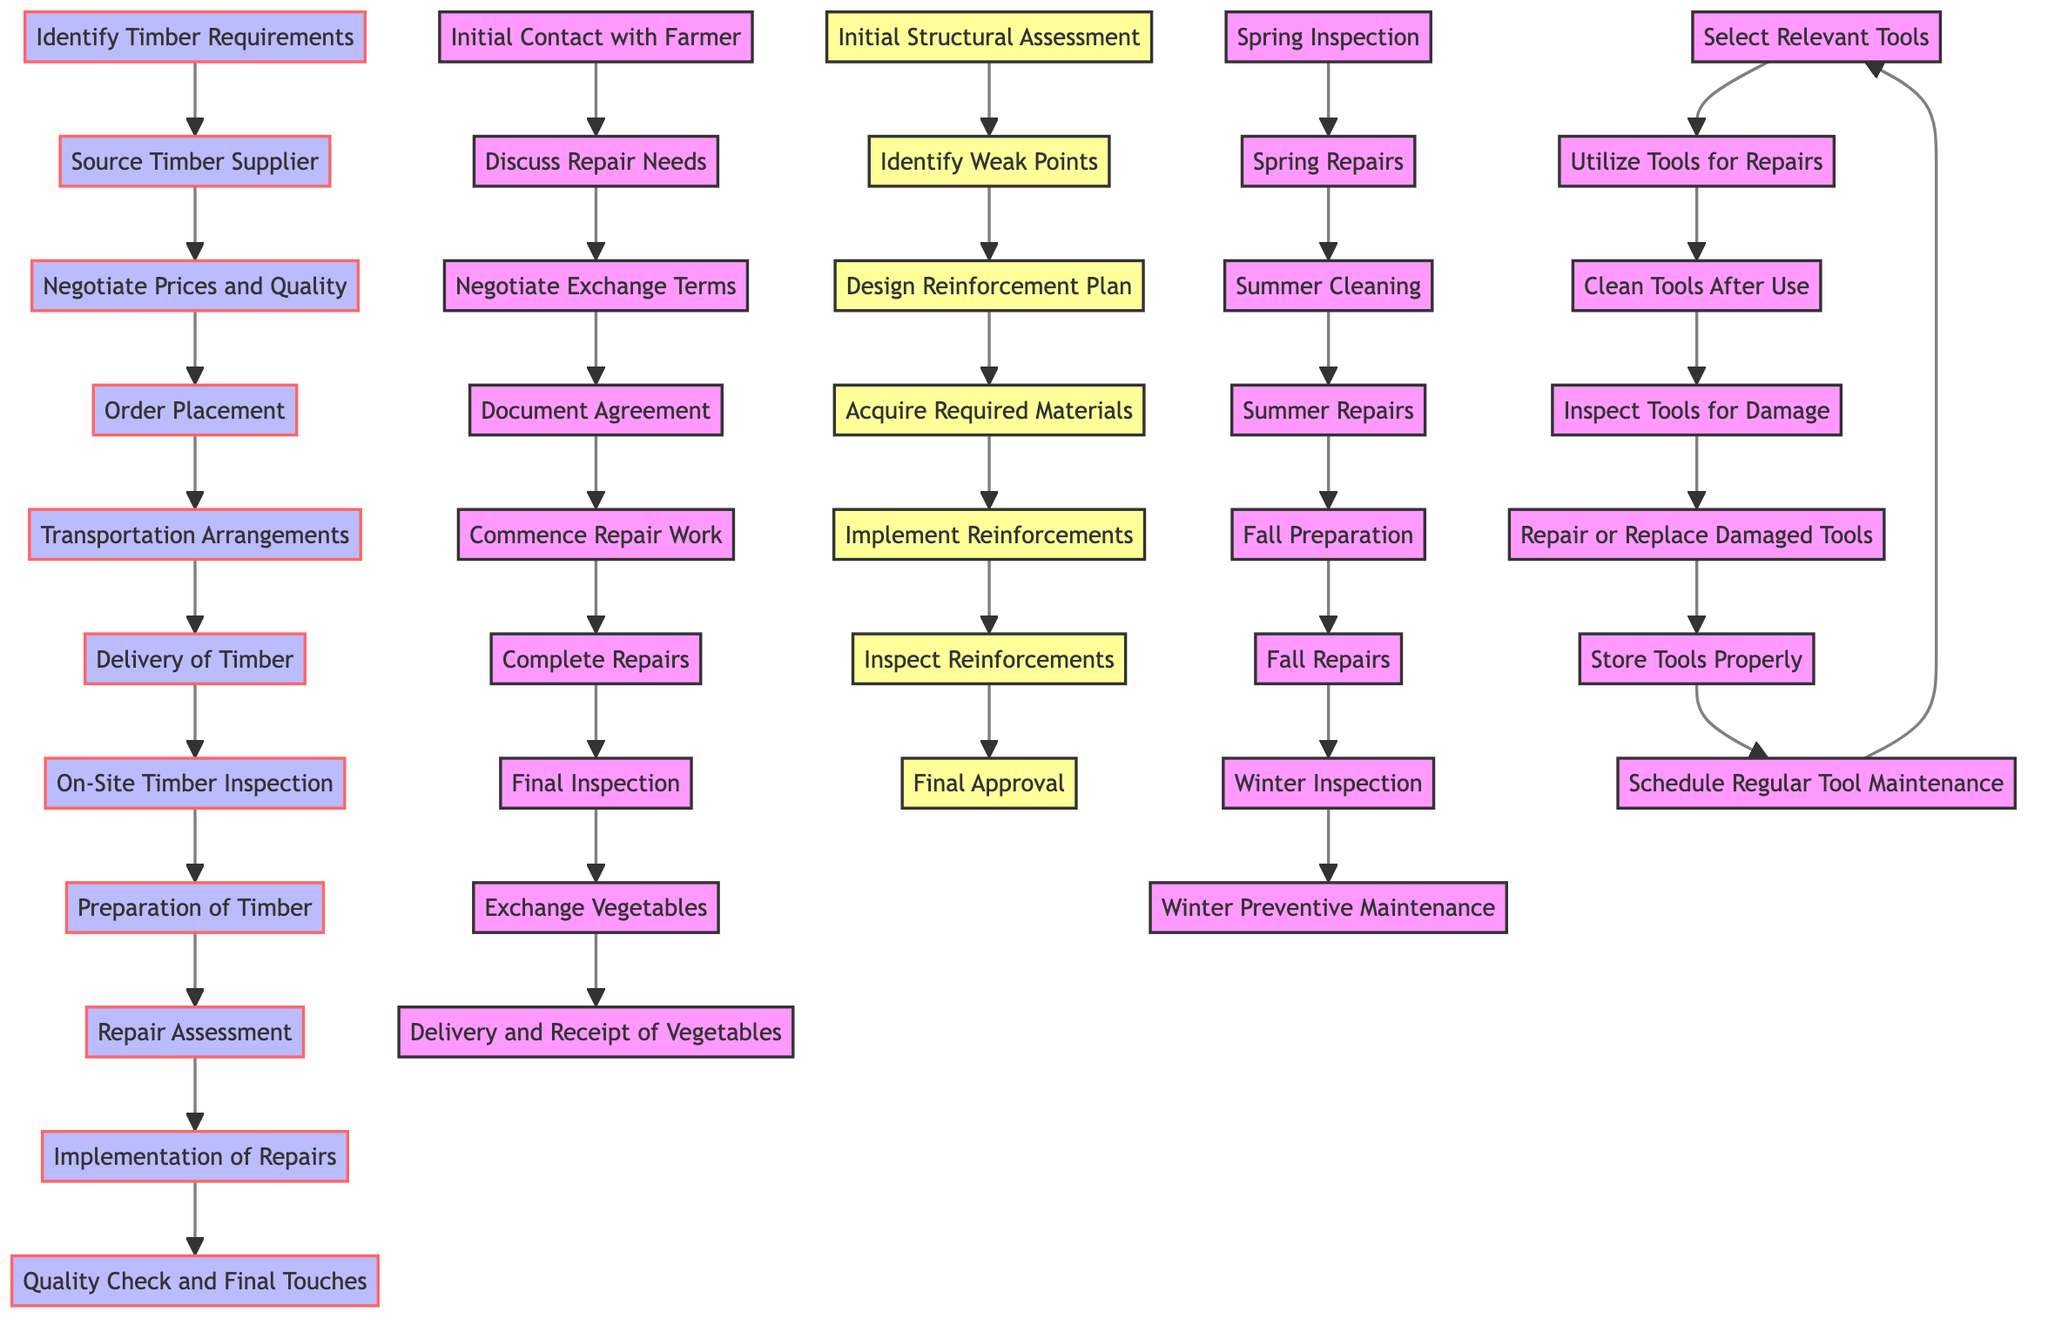What is the first step in the Timber Procurement and Barn Repair Process Flow? The first node in the diagram for Timber Procurement and Barn Repair Process Flow is "Identify Timber Requirements." This is identified by looking at the beginning of the directed graph where the flow starts.
Answer: Identify Timber Requirements How many nodes are present in the Vegetable Exchange Workflow? By counting the individual stages listed in the Vegetable Exchange Workflow section of the diagram, we find there are nine distinct nodes.
Answer: 9 What nodes precede "Complete Repairs" in the Vegetable Exchange Workflow? We trace the edges leading up to "Complete Repairs." The relevant nodes are "Commence Repair Work" and the "Final Inspection," showing the order of processes leading to completion.
Answer: Commence Repair Work, Final Inspection What is the last step after "Inspect Reinforcements" in the Barn Structural Reinforcement Plan? Referring to the directed graph sequence, the step following "Inspect Reinforcements" is "Final Approval." This can be traced directly from the edge that flows from "Inspect Reinforcements."
Answer: Final Approval In the Seasonal Maintenance Schedule, how many repairs happen before Winter Inspection? Reviewing the edges leading up to "Winter Inspection," we find the tasks are "Fall Repairs," "Summer Repairs," "Spring Repairs," totaling three before reaching the Winter Inspection node.
Answer: 3 What is the purpose of the “Schedule Regular Tool Maintenance” node in the Tool Utilization and Maintenance Cycle? This node signifies the planning of regular care for tools, ensuring they remain functional and safe for use. It serves as a preventative measure towards maintaining tool quality.
Answer: Planning regular care for tools Which node directly follows "Delivery of Timber" in the Timber Procurement and Barn Repair Process Flow? The directed edge shows that directly following "Delivery of Timber" is "On-Site Timber Inspection," indicating the sequential flow from delivery to inspection.
Answer: On-Site Timber Inspection Identify the node that connects "Summer Repairs" and "Fall Preparation" in the Seasonal Maintenance Schedule. The edge clearly states that "Summer Repairs" flows to "Fall Preparation," marking the transition from summer tasks to preparing for fall.
Answer: Fall Preparation 